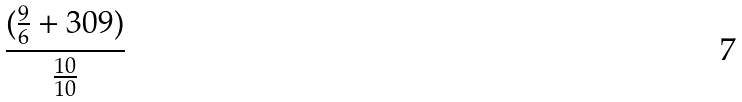<formula> <loc_0><loc_0><loc_500><loc_500>\frac { ( \frac { 9 } { 6 } + 3 0 9 ) } { \frac { 1 0 } { 1 0 } }</formula> 